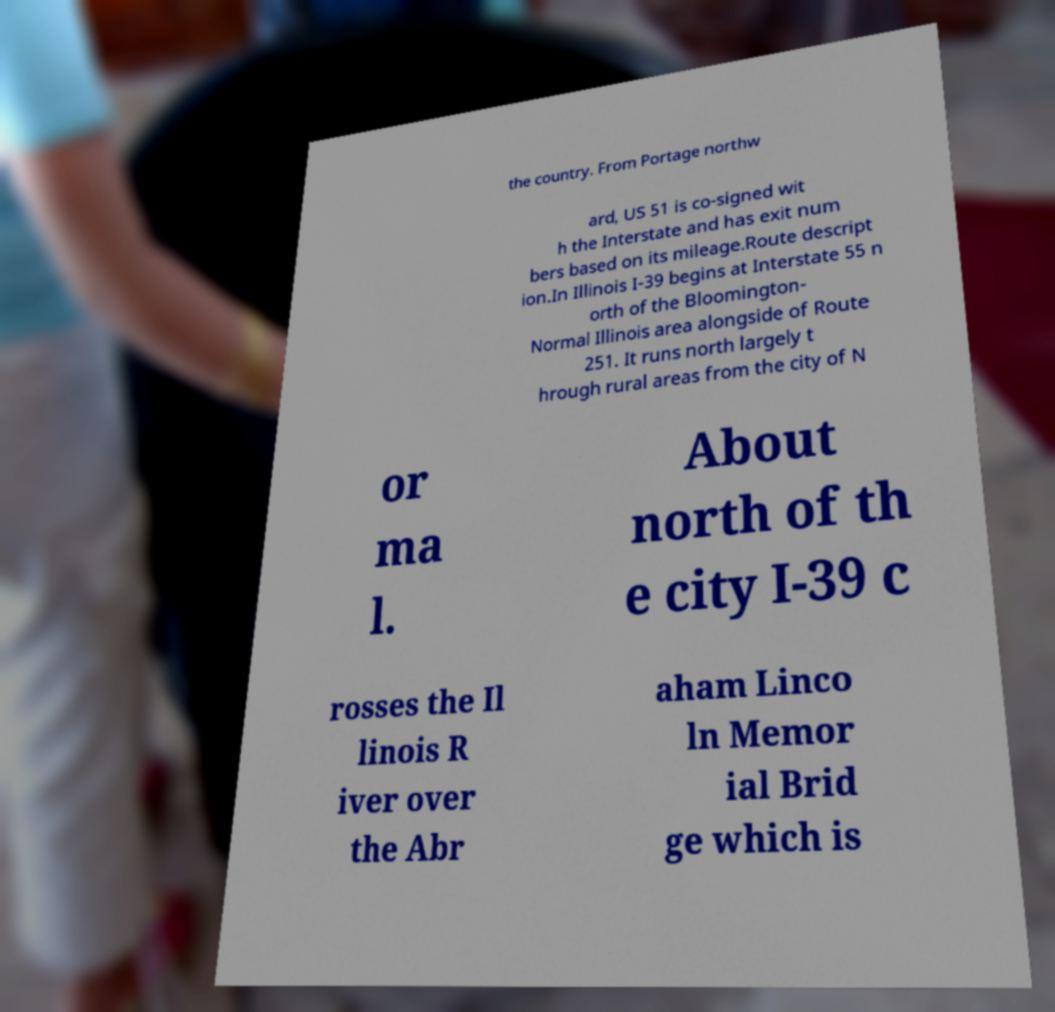Can you accurately transcribe the text from the provided image for me? the country. From Portage northw ard, US 51 is co-signed wit h the Interstate and has exit num bers based on its mileage.Route descript ion.In Illinois I-39 begins at Interstate 55 n orth of the Bloomington- Normal Illinois area alongside of Route 251. It runs north largely t hrough rural areas from the city of N or ma l. About north of th e city I-39 c rosses the Il linois R iver over the Abr aham Linco ln Memor ial Brid ge which is 